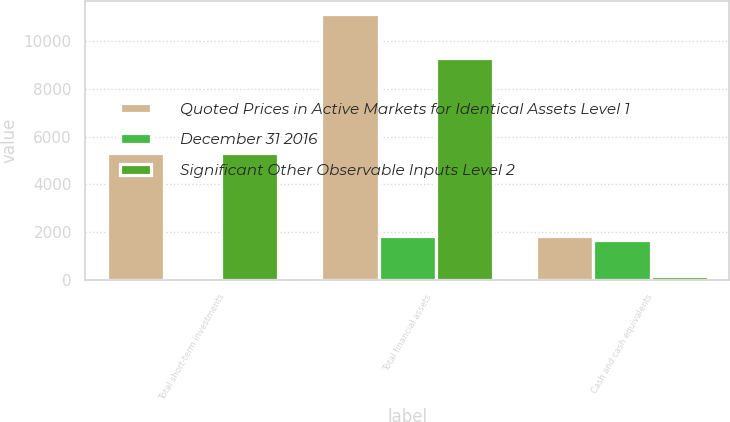Convert chart to OTSL. <chart><loc_0><loc_0><loc_500><loc_500><stacked_bar_chart><ecel><fcel>Total short-term investments<fcel>Total financial assets<fcel>Cash and cash equivalents<nl><fcel>Quoted Prices in Active Markets for Identical Assets Level 1<fcel>5333<fcel>11154<fcel>1832<nl><fcel>December 31 2016<fcel>19<fcel>1835<fcel>1664<nl><fcel>Significant Other Observable Inputs Level 2<fcel>5314<fcel>9319<fcel>168<nl></chart> 